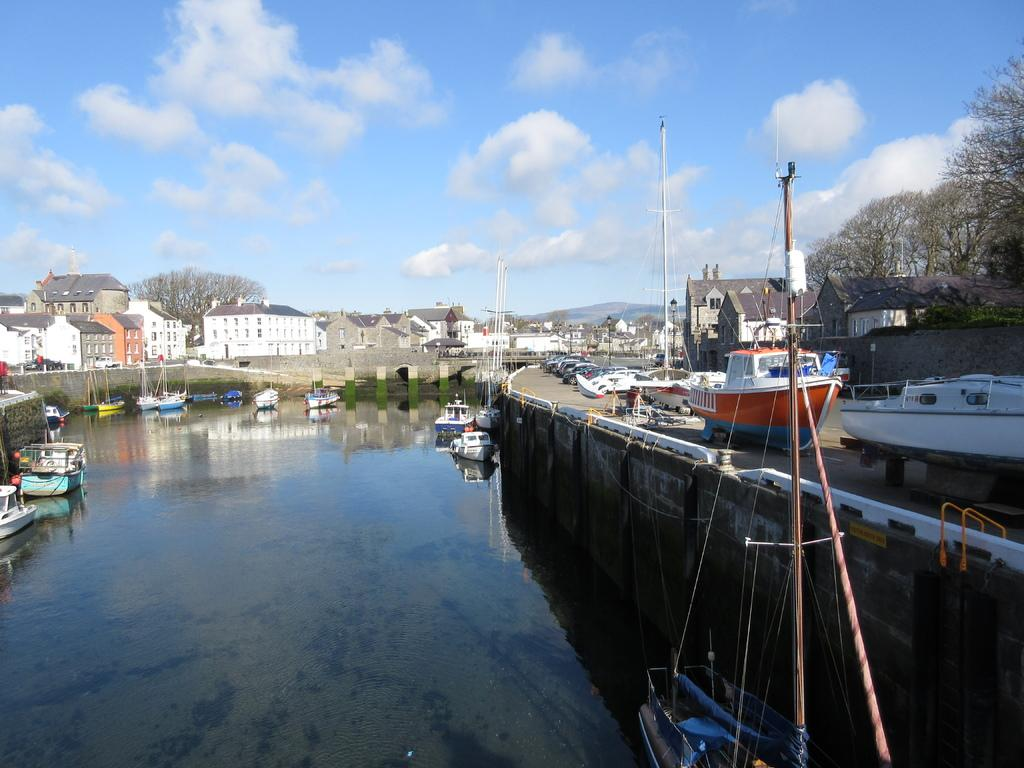What is on the water in the image? There are boats on the water in the image. What other types of transportation can be seen in the image? There are vehicles in the image. What natural elements are present in the image? There are trees and the sky visible in the image. What man-made structures can be seen in the image? There are poles and houses in the image. What is visible in the background of the image? The sky is visible in the background of the image, and there are clouds in the sky. What type of food is being prepared by the mice in the image? There are no mice present in the image, and therefore no food preparation can be observed. Can you see a kite flying in the sky in the image? There is no kite visible in the sky in the image. 